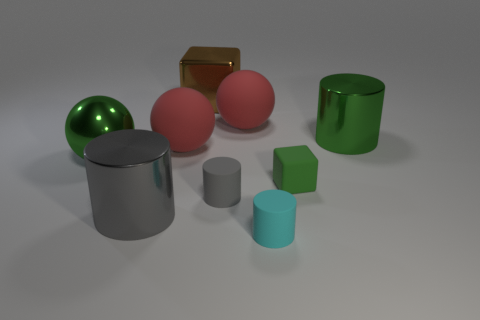What number of big objects are left of the big green metallic cylinder and to the right of the cyan cylinder?
Offer a terse response. 0. Are there more shiny objects left of the big green metal cylinder than big green cylinders?
Give a very brief answer. Yes. How many red balls are the same size as the gray rubber cylinder?
Provide a short and direct response. 0. What size is the rubber thing that is the same color as the metallic sphere?
Keep it short and to the point. Small. What number of big objects are either red balls or green cylinders?
Your answer should be compact. 3. What number of large purple spheres are there?
Offer a very short reply. 0. Are there the same number of large things that are in front of the small cyan object and big red matte spheres that are left of the large brown metal block?
Provide a short and direct response. No. There is a cyan cylinder; are there any matte balls right of it?
Ensure brevity in your answer.  No. There is a big metallic object in front of the large green ball; what color is it?
Make the answer very short. Gray. There is a big gray cylinder that is on the left side of the small rubber object behind the small gray thing; what is it made of?
Your response must be concise. Metal. 